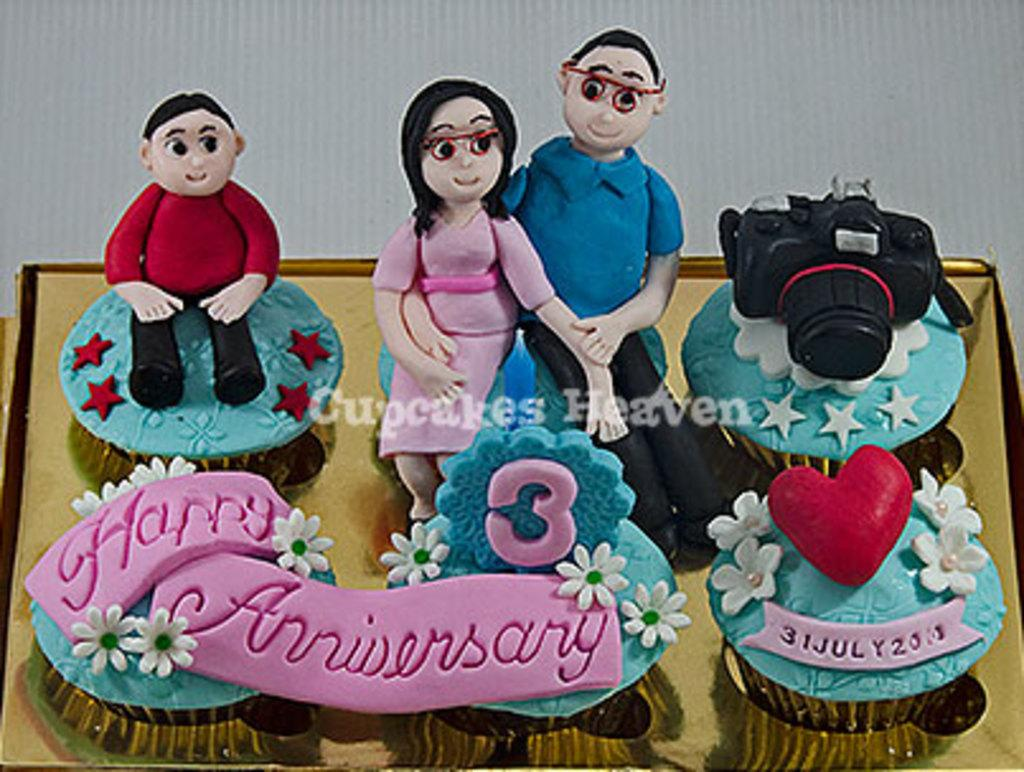What is the main subject of the image? There is a cake in the image. What decorations are on the cake? The cake has artificial flowers on it. What device is visible in the image? There is a camera in the image. What type of objects can be seen in the image besides the cake and camera? There are toys in the image. What can be seen in the background of the image? In the background, there appears to be a cardboard box. What type of fan is used to cool down the cake in the image? There is no fan present in the image, and the cake does not require cooling down. 